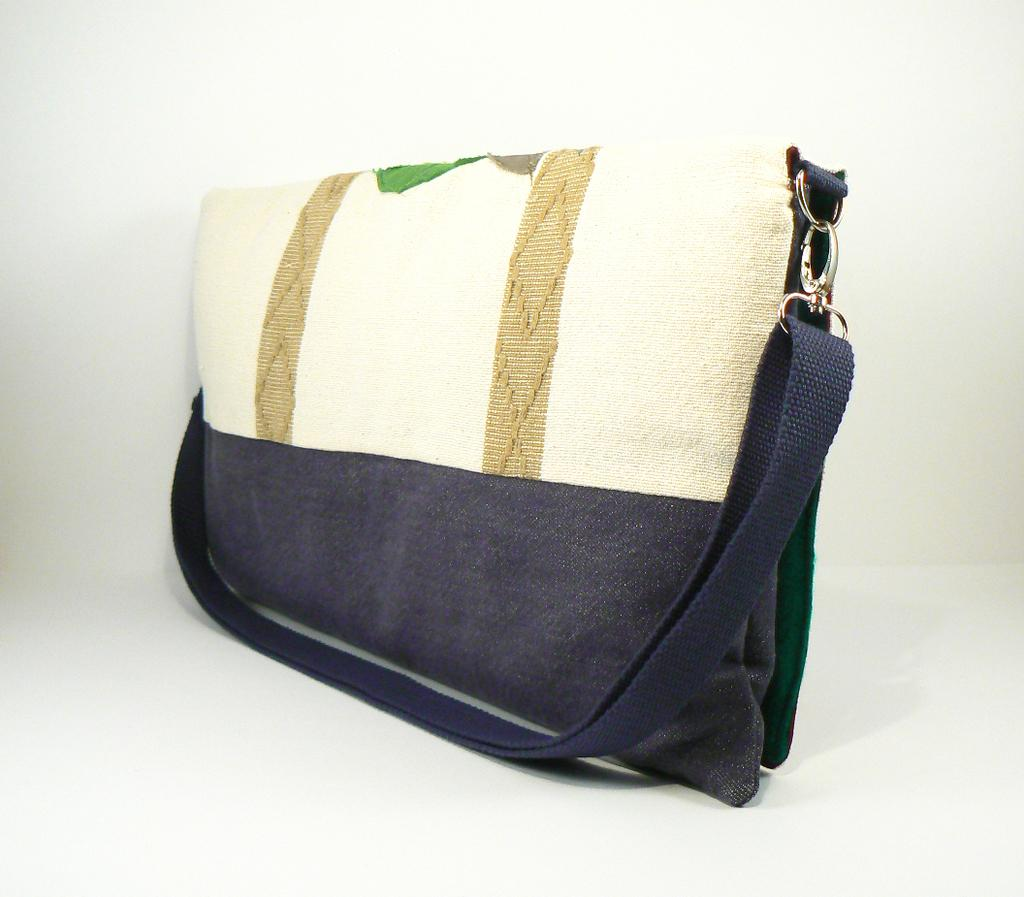What colors are used to design the bag in the image? The bag is blue and cream in color, with two brown color stripes. What is the color of the background in the image? The background color is white. How much money is inside the bag in the image? There is no indication of money or any contents inside the bag in the image. The image only shows the exterior appearance of the bag, with no information about its contents. 